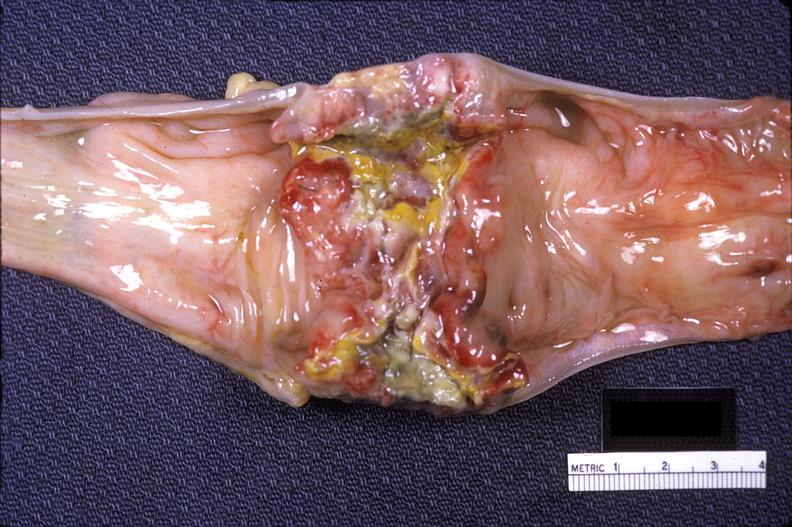s gastrointestinal present?
Answer the question using a single word or phrase. Yes 